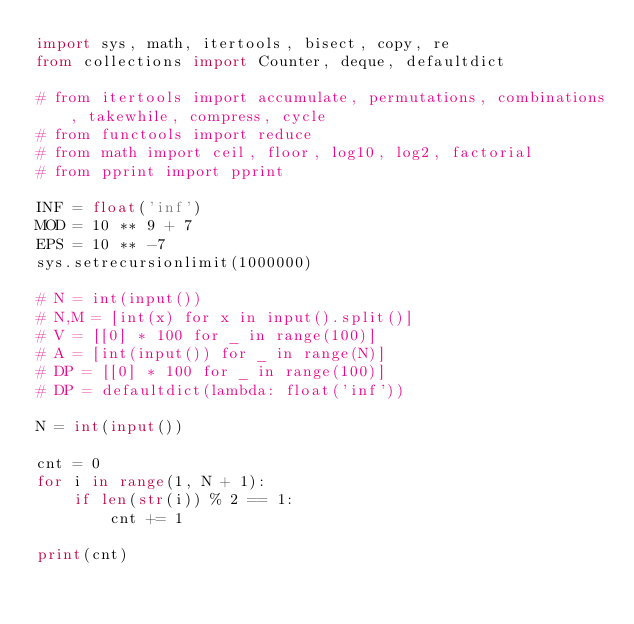Convert code to text. <code><loc_0><loc_0><loc_500><loc_500><_Python_>import sys, math, itertools, bisect, copy, re
from collections import Counter, deque, defaultdict

# from itertools import accumulate, permutations, combinations, takewhile, compress, cycle
# from functools import reduce
# from math import ceil, floor, log10, log2, factorial
# from pprint import pprint

INF = float('inf')
MOD = 10 ** 9 + 7
EPS = 10 ** -7
sys.setrecursionlimit(1000000)

# N = int(input())
# N,M = [int(x) for x in input().split()]
# V = [[0] * 100 for _ in range(100)]
# A = [int(input()) for _ in range(N)]
# DP = [[0] * 100 for _ in range(100)]
# DP = defaultdict(lambda: float('inf'))

N = int(input())

cnt = 0
for i in range(1, N + 1):
    if len(str(i)) % 2 == 1:
        cnt += 1

print(cnt)
</code> 